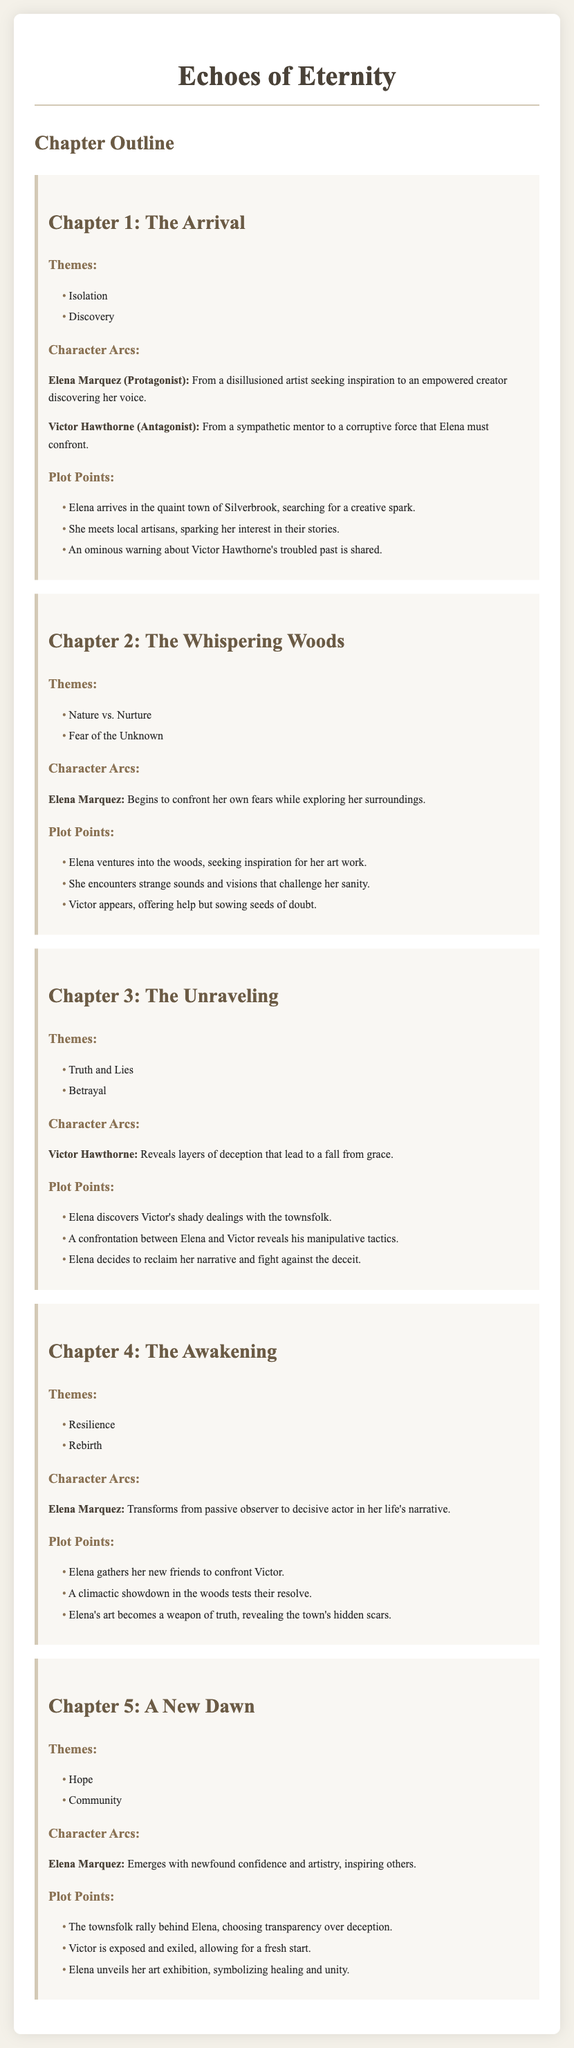What is the title of the novel? The title of the novel is mentioned in the document header.
Answer: Echoes of Eternity How many chapters are in the outline? The document provides a chapter outline with specific chapters listed.
Answer: Five What is the name of the protagonist? The protagonist's name is specified in the character arcs section of Chapter 1.
Answer: Elena Marquez What theme is explored in Chapter 3? Chapter 3 has themes listed, and one is identified in the themes section.
Answer: Truth and Lies In which chapter does Elena confront Victor? The chapter where the confrontation occurs is specified in the plot points.
Answer: Chapter 4 What transformation does Elena undergo? The document describes her character arc and transformation in Chapter 4.
Answer: From passive observer to decisive actor Which character represents a corruptive force? The document explicitly identifies this character in the character arcs section.
Answer: Victor Hawthorne What is the primary theme in Chapter 5? The theme for Chapter 5 is listed in the themes section of that chapter.
Answer: Hope What happens to Victor at the end of the novel? The conclusion regarding this character is provided in the plot points of Chapter 5.
Answer: Exposed and exiled 